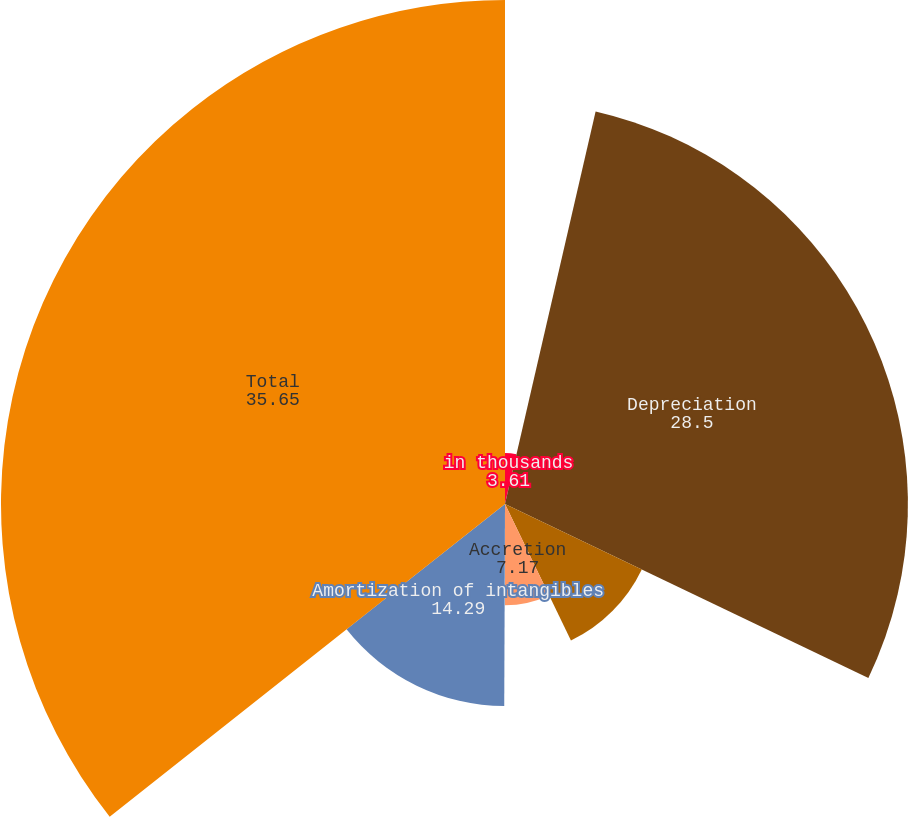Convert chart. <chart><loc_0><loc_0><loc_500><loc_500><pie_chart><fcel>in thousands<fcel>Depreciation<fcel>Depletion<fcel>Accretion<fcel>Amortization of leaseholds<fcel>Amortization of intangibles<fcel>Total<nl><fcel>3.61%<fcel>28.5%<fcel>10.73%<fcel>7.17%<fcel>0.05%<fcel>14.29%<fcel>35.65%<nl></chart> 